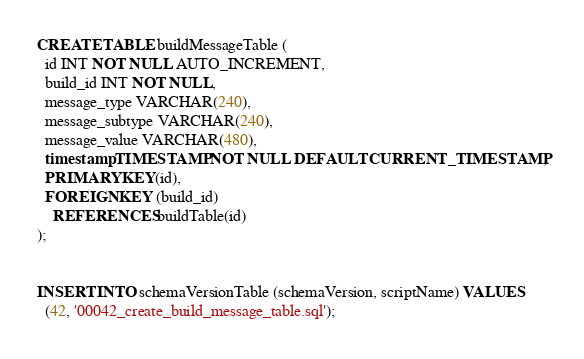Convert code to text. <code><loc_0><loc_0><loc_500><loc_500><_SQL_>CREATE TABLE buildMessageTable (
  id INT NOT NULL AUTO_INCREMENT,
  build_id INT NOT NULL,
  message_type VARCHAR(240),
  message_subtype VARCHAR(240),
  message_value VARCHAR(480),
  timestamp TIMESTAMP NOT NULL DEFAULT CURRENT_TIMESTAMP,
  PRIMARY KEY(id),
  FOREIGN KEY (build_id)
    REFERENCES buildTable(id)
);


INSERT INTO schemaVersionTable (schemaVersion, scriptName) VALUES
  (42, '00042_create_build_message_table.sql');
</code> 